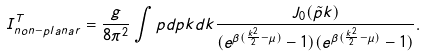Convert formula to latex. <formula><loc_0><loc_0><loc_500><loc_500>I _ { n o n - p l a n a r } ^ { T } = \frac { g } { 8 \pi ^ { 2 } } \int p d p k d k \frac { J _ { 0 } ( \tilde { p } k ) } { ( e ^ { \beta ( \frac { k ^ { 2 } } { 2 } - \mu ) } - 1 ) ( e ^ { \beta ( \frac { k ^ { 2 } } { 2 } - \mu ) } - 1 ) } .</formula> 